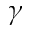Convert formula to latex. <formula><loc_0><loc_0><loc_500><loc_500>\gamma</formula> 